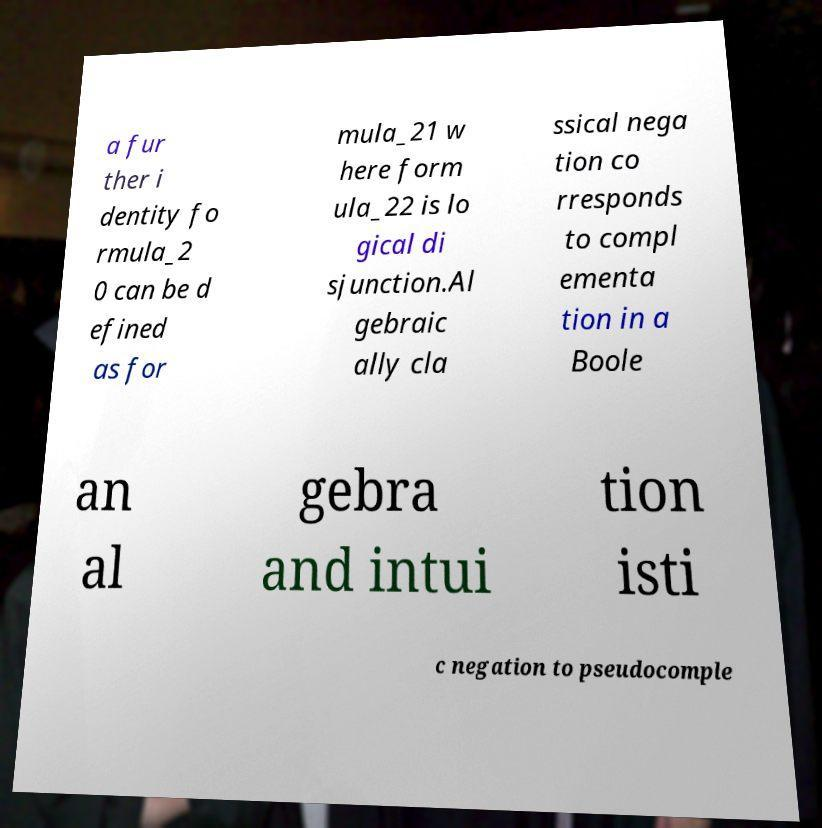There's text embedded in this image that I need extracted. Can you transcribe it verbatim? a fur ther i dentity fo rmula_2 0 can be d efined as for mula_21 w here form ula_22 is lo gical di sjunction.Al gebraic ally cla ssical nega tion co rresponds to compl ementa tion in a Boole an al gebra and intui tion isti c negation to pseudocomple 